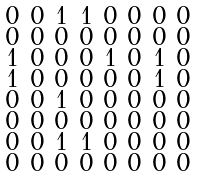Convert formula to latex. <formula><loc_0><loc_0><loc_500><loc_500>\begin{smallmatrix} 0 & 0 & 1 & 1 & 0 & 0 & 0 & 0 \\ 0 & 0 & 0 & 0 & 0 & 0 & 0 & 0 \\ 1 & 0 & 0 & 0 & 1 & 0 & 1 & 0 \\ 1 & 0 & 0 & 0 & 0 & 0 & 1 & 0 \\ 0 & 0 & 1 & 0 & 0 & 0 & 0 & 0 \\ 0 & 0 & 0 & 0 & 0 & 0 & 0 & 0 \\ 0 & 0 & 1 & 1 & 0 & 0 & 0 & 0 \\ 0 & 0 & 0 & 0 & 0 & 0 & 0 & 0 \end{smallmatrix}</formula> 